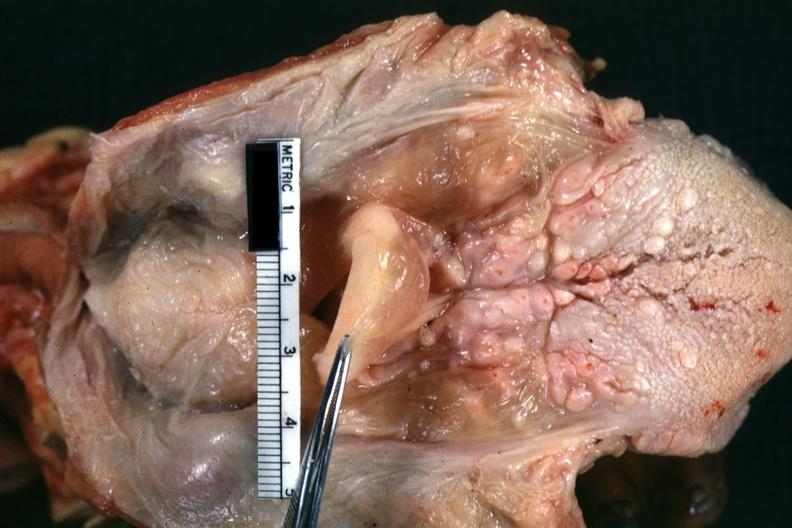s hypopharyngeal edema present?
Answer the question using a single word or phrase. Yes 